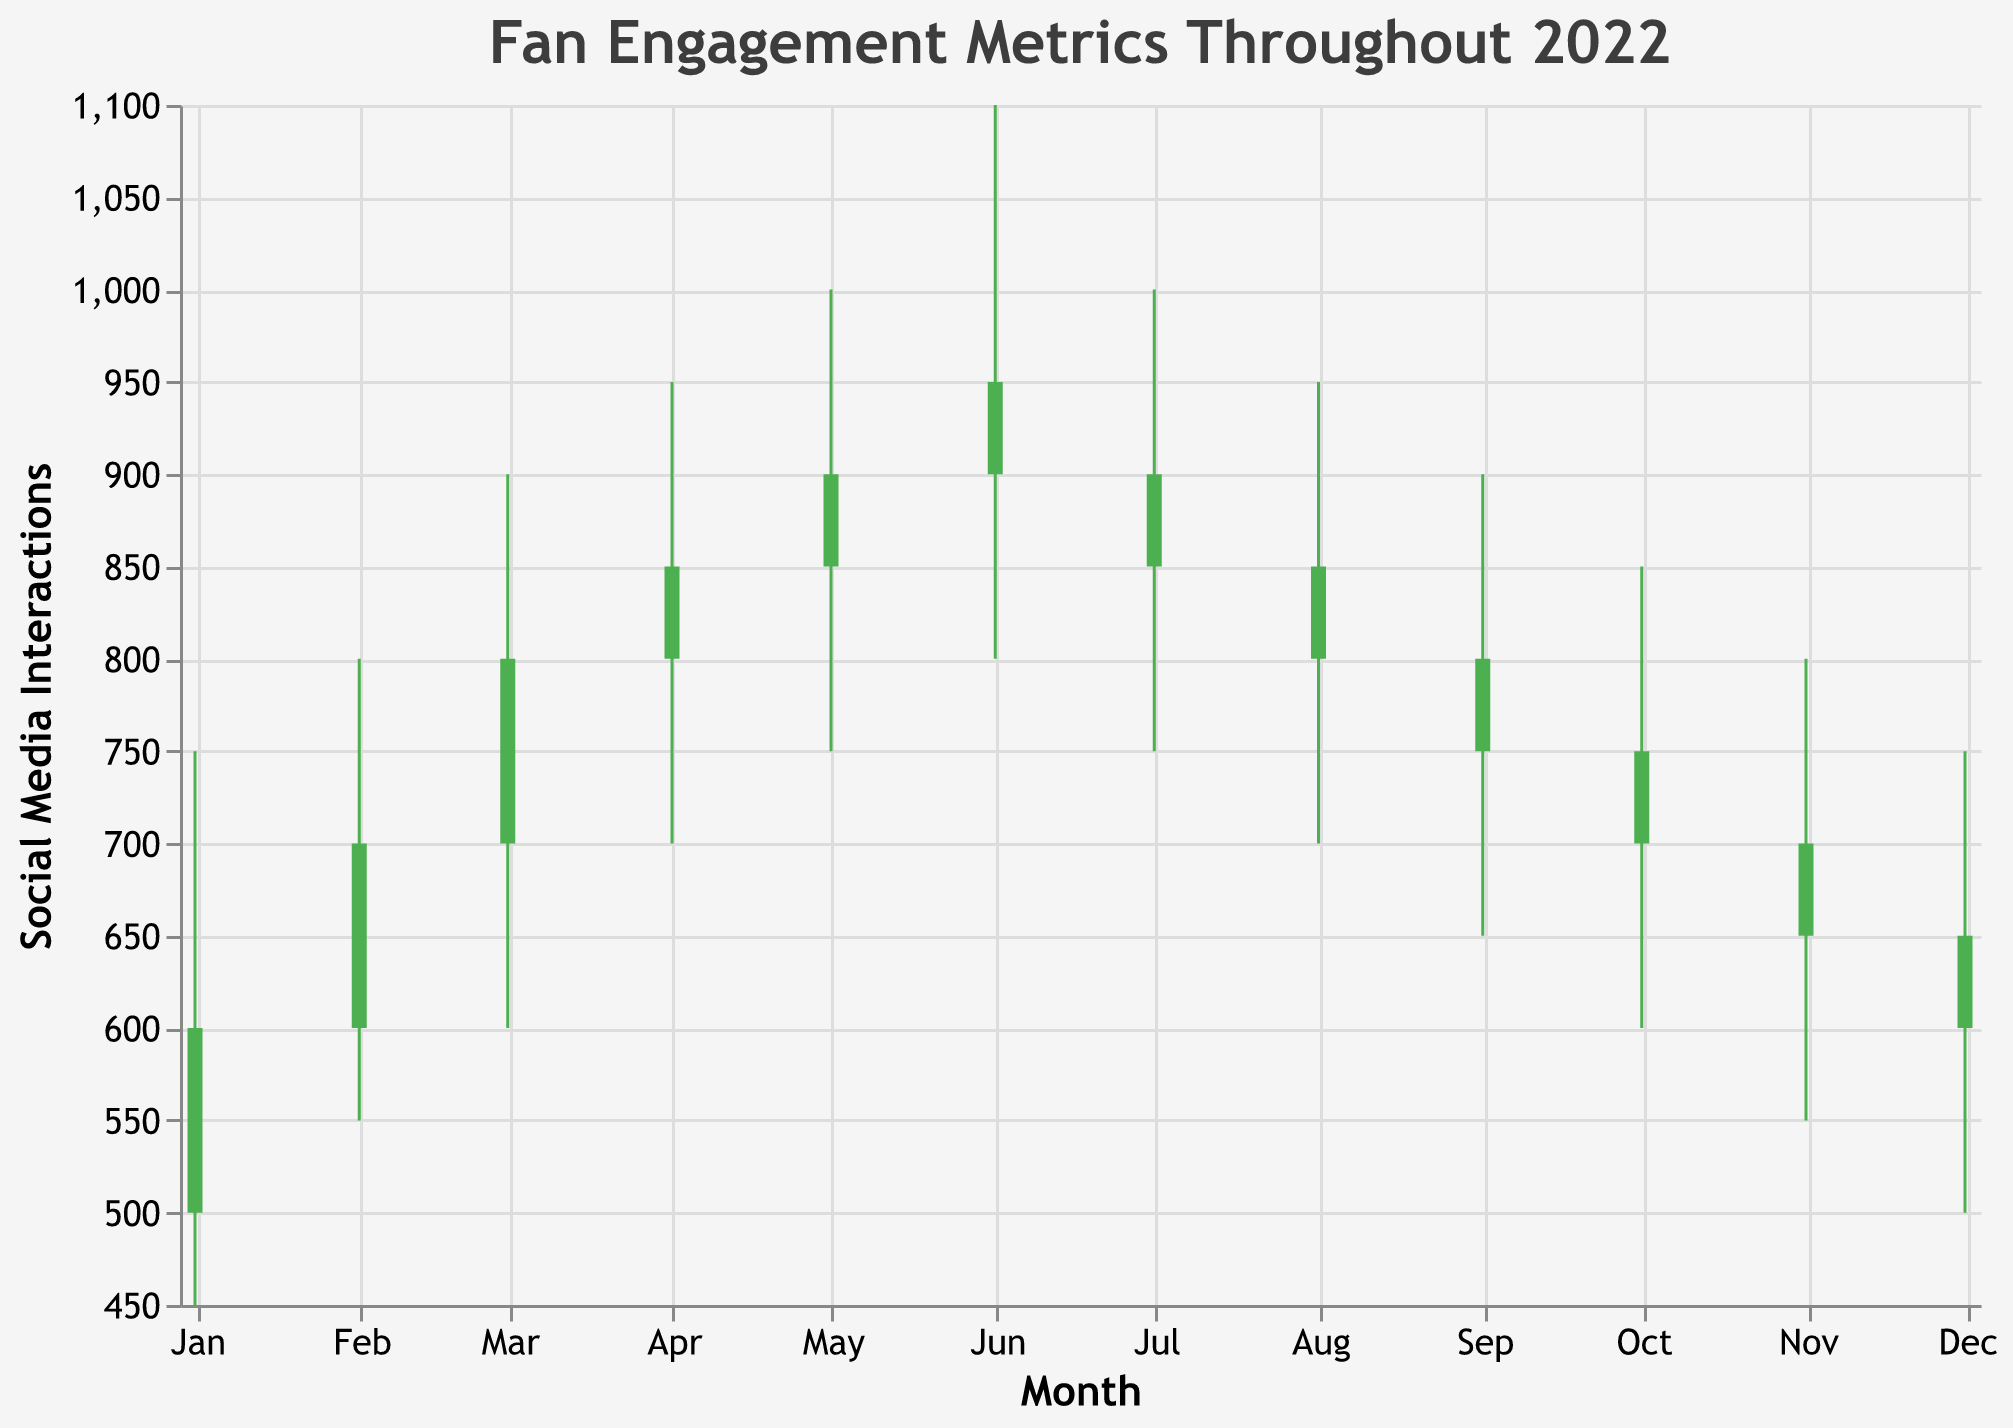What's the title of the figure? The title is displayed at the top of the plot and is "Fan Engagement Metrics Throughout 2022".
Answer: Fan Engagement Metrics Throughout 2022 What does the x-axis represent? The x-axis is labeled as "Month" and shows the dates of each month in 2022.
Answer: Month What does the y-axis represent? The y-axis is labeled as "Social Media Interactions" and measures the number of social media interactions.
Answer: Social Media Interactions Which color indicates that the closing value is higher than the opening value? The green color indicates a positive change where the closing value is higher than the opening value.
Answer: Green Which month had the highest 'High Social Media Interactions' value? In the figure, the month with the highest 'High Social Media Interactions' is June with a value of 1100.
Answer: June Which months had a decrease in Social Media Interactions from open to close? These months are indicated by the red bars: July, August, September, October, November, and December.
Answer: July, August, September, October, November, December What is the difference between the high and low social media interactions in April? The high value in April is 950, and the low value is 700. The difference is 950 - 700.
Answer: 250 How many months showed an increase in Social Media Interactions from the opening to the closing values? The green bars indicate months with an increase, which are January, February, March, April, May, and June.
Answer: 6 What is the average high social media interactions value across the year? Sum the high values from each month and divide by the number of months: (750 + 800 + 900 + 950 + 1000 + 1100 + 1000 + 950 + 900 + 850 + 800 + 750) / 12.
Answer: 908.33 In which months did social media interactions close lower than they opened and match attendance also show a decrease? We need to look for red bars in Social Media Interactions and also check if Close Attendance is lower than Open Attendance. These months are July, August, September, October, November, and December.
Answer: July, August, September, October, November, December 